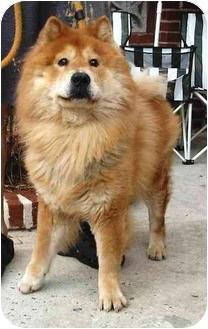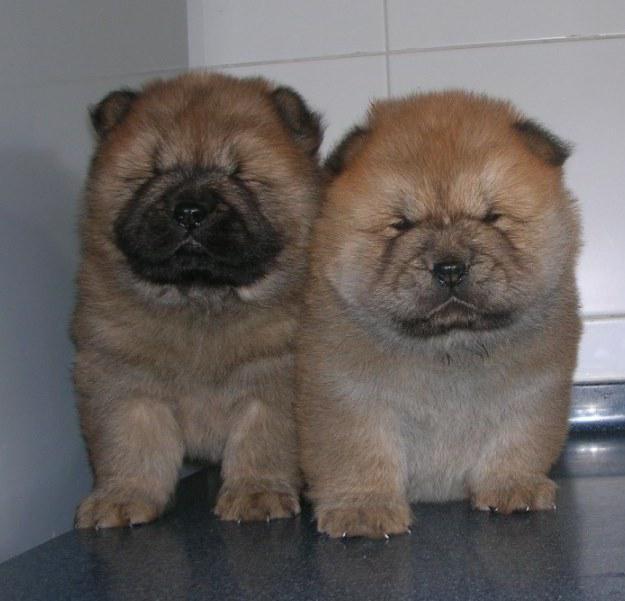The first image is the image on the left, the second image is the image on the right. Analyze the images presented: Is the assertion "A single dog is standing on all fours in the image on the right." valid? Answer yes or no. No. The first image is the image on the left, the second image is the image on the right. Analyze the images presented: Is the assertion "The combined images include two fluffy puppies with similar poses, expressions and colors." valid? Answer yes or no. Yes. 